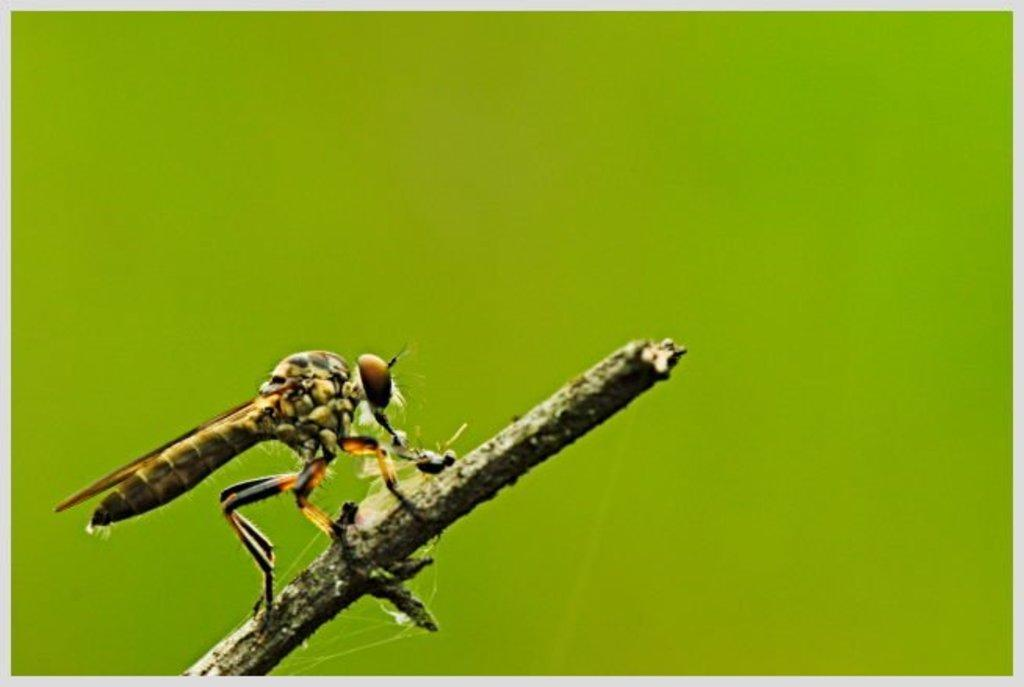What type of creature is present in the image? There is an insect in the image. Where is the insect located in the image? The insect is on a stem. What is the color of the background in the image? The background of the image is green in color. How many bridges can be seen crossing the sand in the image? There are no bridges or sand present in the image. What type of creature is shown interacting with the insect on the stem in the image? There is no other creature shown interacting with the insect on the stem in the image. 